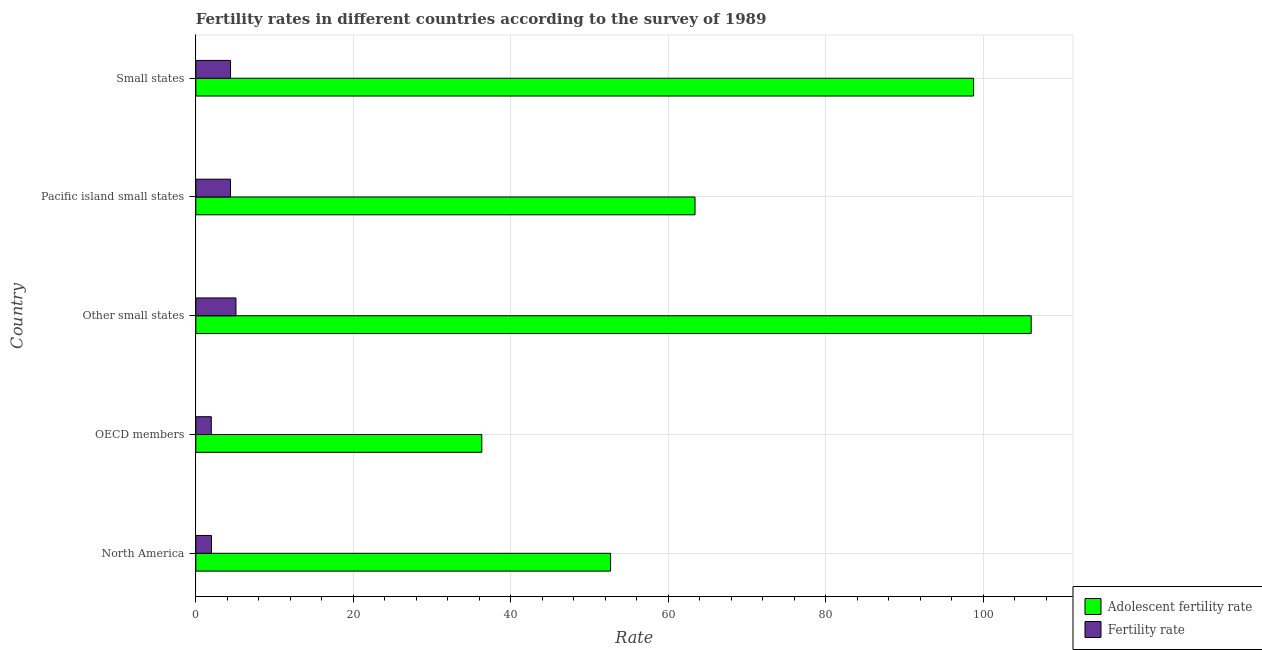Are the number of bars per tick equal to the number of legend labels?
Make the answer very short. Yes. Are the number of bars on each tick of the Y-axis equal?
Ensure brevity in your answer.  Yes. How many bars are there on the 5th tick from the top?
Make the answer very short. 2. What is the label of the 1st group of bars from the top?
Make the answer very short. Small states. What is the adolescent fertility rate in Pacific island small states?
Make the answer very short. 63.39. Across all countries, what is the maximum adolescent fertility rate?
Offer a very short reply. 106.08. Across all countries, what is the minimum fertility rate?
Your answer should be compact. 1.96. In which country was the fertility rate maximum?
Your answer should be very brief. Other small states. What is the total adolescent fertility rate in the graph?
Your response must be concise. 357.23. What is the difference between the adolescent fertility rate in North America and that in Small states?
Provide a succinct answer. -46.1. What is the difference between the fertility rate in Pacific island small states and the adolescent fertility rate in North America?
Provide a succinct answer. -48.27. What is the average fertility rate per country?
Make the answer very short. 3.57. What is the difference between the adolescent fertility rate and fertility rate in Small states?
Provide a short and direct response. 94.36. In how many countries, is the adolescent fertility rate greater than 20 ?
Provide a short and direct response. 5. What is the ratio of the adolescent fertility rate in North America to that in OECD members?
Make the answer very short. 1.45. Is the adolescent fertility rate in North America less than that in Small states?
Make the answer very short. Yes. Is the difference between the adolescent fertility rate in North America and Small states greater than the difference between the fertility rate in North America and Small states?
Your response must be concise. No. What is the difference between the highest and the second highest fertility rate?
Provide a short and direct response. 0.69. What is the difference between the highest and the lowest fertility rate?
Give a very brief answer. 3.13. In how many countries, is the adolescent fertility rate greater than the average adolescent fertility rate taken over all countries?
Make the answer very short. 2. What does the 1st bar from the top in OECD members represents?
Provide a short and direct response. Fertility rate. What does the 1st bar from the bottom in OECD members represents?
Your answer should be very brief. Adolescent fertility rate. Are all the bars in the graph horizontal?
Your response must be concise. Yes. How many countries are there in the graph?
Keep it short and to the point. 5. What is the difference between two consecutive major ticks on the X-axis?
Make the answer very short. 20. Are the values on the major ticks of X-axis written in scientific E-notation?
Ensure brevity in your answer.  No. Does the graph contain grids?
Offer a terse response. Yes. What is the title of the graph?
Make the answer very short. Fertility rates in different countries according to the survey of 1989. What is the label or title of the X-axis?
Your response must be concise. Rate. What is the label or title of the Y-axis?
Provide a short and direct response. Country. What is the Rate in Adolescent fertility rate in North America?
Provide a short and direct response. 52.67. What is the Rate of Fertility rate in North America?
Make the answer very short. 1.99. What is the Rate of Adolescent fertility rate in OECD members?
Ensure brevity in your answer.  36.32. What is the Rate in Fertility rate in OECD members?
Keep it short and to the point. 1.96. What is the Rate of Adolescent fertility rate in Other small states?
Your answer should be compact. 106.08. What is the Rate of Fertility rate in Other small states?
Offer a terse response. 5.1. What is the Rate of Adolescent fertility rate in Pacific island small states?
Your answer should be compact. 63.39. What is the Rate in Fertility rate in Pacific island small states?
Offer a very short reply. 4.4. What is the Rate in Adolescent fertility rate in Small states?
Ensure brevity in your answer.  98.77. What is the Rate of Fertility rate in Small states?
Your response must be concise. 4.41. Across all countries, what is the maximum Rate of Adolescent fertility rate?
Your answer should be very brief. 106.08. Across all countries, what is the maximum Rate in Fertility rate?
Ensure brevity in your answer.  5.1. Across all countries, what is the minimum Rate in Adolescent fertility rate?
Make the answer very short. 36.32. Across all countries, what is the minimum Rate in Fertility rate?
Keep it short and to the point. 1.96. What is the total Rate of Adolescent fertility rate in the graph?
Keep it short and to the point. 357.23. What is the total Rate in Fertility rate in the graph?
Make the answer very short. 17.86. What is the difference between the Rate in Adolescent fertility rate in North America and that in OECD members?
Provide a succinct answer. 16.35. What is the difference between the Rate of Fertility rate in North America and that in OECD members?
Offer a very short reply. 0.03. What is the difference between the Rate of Adolescent fertility rate in North America and that in Other small states?
Your answer should be compact. -53.41. What is the difference between the Rate in Fertility rate in North America and that in Other small states?
Your answer should be very brief. -3.11. What is the difference between the Rate in Adolescent fertility rate in North America and that in Pacific island small states?
Keep it short and to the point. -10.72. What is the difference between the Rate in Fertility rate in North America and that in Pacific island small states?
Your answer should be very brief. -2.42. What is the difference between the Rate in Adolescent fertility rate in North America and that in Small states?
Your response must be concise. -46.1. What is the difference between the Rate of Fertility rate in North America and that in Small states?
Your answer should be very brief. -2.42. What is the difference between the Rate in Adolescent fertility rate in OECD members and that in Other small states?
Ensure brevity in your answer.  -69.77. What is the difference between the Rate of Fertility rate in OECD members and that in Other small states?
Keep it short and to the point. -3.13. What is the difference between the Rate in Adolescent fertility rate in OECD members and that in Pacific island small states?
Your response must be concise. -27.08. What is the difference between the Rate in Fertility rate in OECD members and that in Pacific island small states?
Provide a succinct answer. -2.44. What is the difference between the Rate in Adolescent fertility rate in OECD members and that in Small states?
Make the answer very short. -62.45. What is the difference between the Rate of Fertility rate in OECD members and that in Small states?
Provide a succinct answer. -2.44. What is the difference between the Rate of Adolescent fertility rate in Other small states and that in Pacific island small states?
Offer a terse response. 42.69. What is the difference between the Rate of Fertility rate in Other small states and that in Pacific island small states?
Offer a very short reply. 0.69. What is the difference between the Rate in Adolescent fertility rate in Other small states and that in Small states?
Make the answer very short. 7.32. What is the difference between the Rate in Fertility rate in Other small states and that in Small states?
Your answer should be compact. 0.69. What is the difference between the Rate of Adolescent fertility rate in Pacific island small states and that in Small states?
Your response must be concise. -35.37. What is the difference between the Rate in Fertility rate in Pacific island small states and that in Small states?
Offer a terse response. -0. What is the difference between the Rate of Adolescent fertility rate in North America and the Rate of Fertility rate in OECD members?
Your answer should be very brief. 50.71. What is the difference between the Rate in Adolescent fertility rate in North America and the Rate in Fertility rate in Other small states?
Make the answer very short. 47.58. What is the difference between the Rate of Adolescent fertility rate in North America and the Rate of Fertility rate in Pacific island small states?
Keep it short and to the point. 48.27. What is the difference between the Rate of Adolescent fertility rate in North America and the Rate of Fertility rate in Small states?
Provide a succinct answer. 48.26. What is the difference between the Rate in Adolescent fertility rate in OECD members and the Rate in Fertility rate in Other small states?
Make the answer very short. 31.22. What is the difference between the Rate in Adolescent fertility rate in OECD members and the Rate in Fertility rate in Pacific island small states?
Make the answer very short. 31.91. What is the difference between the Rate in Adolescent fertility rate in OECD members and the Rate in Fertility rate in Small states?
Offer a terse response. 31.91. What is the difference between the Rate in Adolescent fertility rate in Other small states and the Rate in Fertility rate in Pacific island small states?
Your answer should be very brief. 101.68. What is the difference between the Rate in Adolescent fertility rate in Other small states and the Rate in Fertility rate in Small states?
Offer a very short reply. 101.68. What is the difference between the Rate of Adolescent fertility rate in Pacific island small states and the Rate of Fertility rate in Small states?
Your response must be concise. 58.99. What is the average Rate in Adolescent fertility rate per country?
Make the answer very short. 71.45. What is the average Rate of Fertility rate per country?
Make the answer very short. 3.57. What is the difference between the Rate in Adolescent fertility rate and Rate in Fertility rate in North America?
Provide a short and direct response. 50.68. What is the difference between the Rate of Adolescent fertility rate and Rate of Fertility rate in OECD members?
Give a very brief answer. 34.35. What is the difference between the Rate of Adolescent fertility rate and Rate of Fertility rate in Other small states?
Give a very brief answer. 100.99. What is the difference between the Rate of Adolescent fertility rate and Rate of Fertility rate in Pacific island small states?
Offer a terse response. 58.99. What is the difference between the Rate of Adolescent fertility rate and Rate of Fertility rate in Small states?
Your answer should be compact. 94.36. What is the ratio of the Rate of Adolescent fertility rate in North America to that in OECD members?
Provide a short and direct response. 1.45. What is the ratio of the Rate of Fertility rate in North America to that in OECD members?
Your answer should be compact. 1.01. What is the ratio of the Rate in Adolescent fertility rate in North America to that in Other small states?
Your answer should be compact. 0.5. What is the ratio of the Rate in Fertility rate in North America to that in Other small states?
Keep it short and to the point. 0.39. What is the ratio of the Rate in Adolescent fertility rate in North America to that in Pacific island small states?
Make the answer very short. 0.83. What is the ratio of the Rate in Fertility rate in North America to that in Pacific island small states?
Offer a terse response. 0.45. What is the ratio of the Rate of Adolescent fertility rate in North America to that in Small states?
Keep it short and to the point. 0.53. What is the ratio of the Rate of Fertility rate in North America to that in Small states?
Keep it short and to the point. 0.45. What is the ratio of the Rate of Adolescent fertility rate in OECD members to that in Other small states?
Your answer should be compact. 0.34. What is the ratio of the Rate in Fertility rate in OECD members to that in Other small states?
Ensure brevity in your answer.  0.39. What is the ratio of the Rate of Adolescent fertility rate in OECD members to that in Pacific island small states?
Provide a short and direct response. 0.57. What is the ratio of the Rate of Fertility rate in OECD members to that in Pacific island small states?
Provide a short and direct response. 0.45. What is the ratio of the Rate of Adolescent fertility rate in OECD members to that in Small states?
Your answer should be very brief. 0.37. What is the ratio of the Rate in Fertility rate in OECD members to that in Small states?
Make the answer very short. 0.45. What is the ratio of the Rate in Adolescent fertility rate in Other small states to that in Pacific island small states?
Give a very brief answer. 1.67. What is the ratio of the Rate in Fertility rate in Other small states to that in Pacific island small states?
Provide a succinct answer. 1.16. What is the ratio of the Rate in Adolescent fertility rate in Other small states to that in Small states?
Provide a succinct answer. 1.07. What is the ratio of the Rate in Fertility rate in Other small states to that in Small states?
Your response must be concise. 1.16. What is the ratio of the Rate of Adolescent fertility rate in Pacific island small states to that in Small states?
Offer a terse response. 0.64. What is the ratio of the Rate in Fertility rate in Pacific island small states to that in Small states?
Offer a terse response. 1. What is the difference between the highest and the second highest Rate of Adolescent fertility rate?
Ensure brevity in your answer.  7.32. What is the difference between the highest and the second highest Rate in Fertility rate?
Provide a short and direct response. 0.69. What is the difference between the highest and the lowest Rate of Adolescent fertility rate?
Offer a terse response. 69.77. What is the difference between the highest and the lowest Rate of Fertility rate?
Provide a short and direct response. 3.13. 